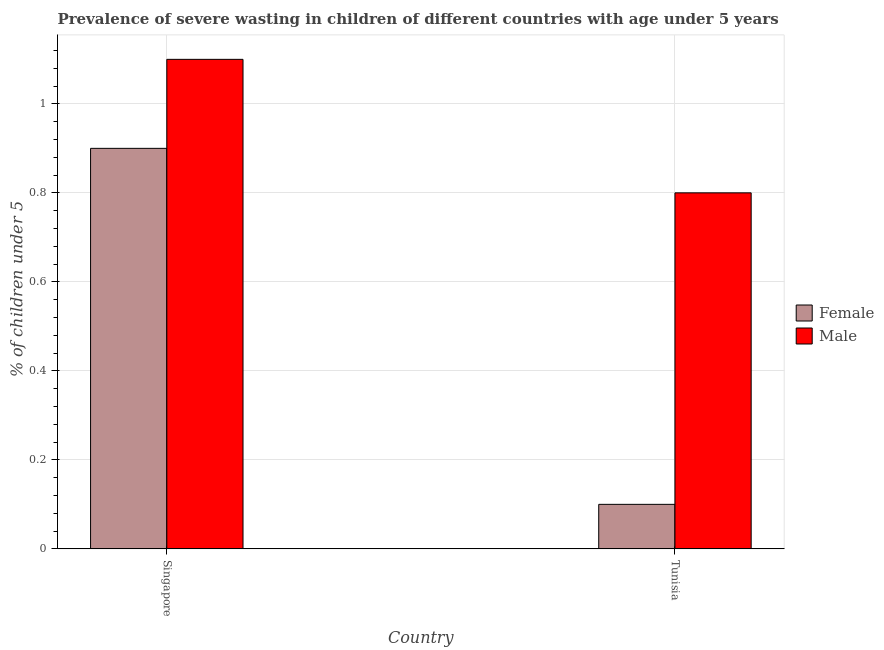How many different coloured bars are there?
Your response must be concise. 2. Are the number of bars per tick equal to the number of legend labels?
Your answer should be very brief. Yes. How many bars are there on the 2nd tick from the right?
Provide a succinct answer. 2. What is the label of the 1st group of bars from the left?
Provide a short and direct response. Singapore. What is the percentage of undernourished male children in Tunisia?
Ensure brevity in your answer.  0.8. Across all countries, what is the maximum percentage of undernourished male children?
Make the answer very short. 1.1. Across all countries, what is the minimum percentage of undernourished male children?
Provide a short and direct response. 0.8. In which country was the percentage of undernourished male children maximum?
Provide a succinct answer. Singapore. In which country was the percentage of undernourished female children minimum?
Your answer should be very brief. Tunisia. What is the total percentage of undernourished female children in the graph?
Offer a terse response. 1. What is the difference between the percentage of undernourished female children in Singapore and that in Tunisia?
Give a very brief answer. 0.8. What is the difference between the percentage of undernourished male children in Tunisia and the percentage of undernourished female children in Singapore?
Give a very brief answer. -0.1. What is the average percentage of undernourished female children per country?
Your answer should be very brief. 0.5. What is the difference between the percentage of undernourished male children and percentage of undernourished female children in Singapore?
Offer a terse response. 0.2. In how many countries, is the percentage of undernourished male children greater than 0.88 %?
Your answer should be very brief. 1. What is the ratio of the percentage of undernourished male children in Singapore to that in Tunisia?
Make the answer very short. 1.38. Is the percentage of undernourished female children in Singapore less than that in Tunisia?
Your answer should be very brief. No. What does the 1st bar from the right in Tunisia represents?
Give a very brief answer. Male. How many bars are there?
Make the answer very short. 4. Are all the bars in the graph horizontal?
Your response must be concise. No. What is the difference between two consecutive major ticks on the Y-axis?
Your response must be concise. 0.2. Are the values on the major ticks of Y-axis written in scientific E-notation?
Make the answer very short. No. Does the graph contain any zero values?
Offer a very short reply. No. Does the graph contain grids?
Your answer should be compact. Yes. Where does the legend appear in the graph?
Provide a short and direct response. Center right. What is the title of the graph?
Provide a short and direct response. Prevalence of severe wasting in children of different countries with age under 5 years. What is the label or title of the X-axis?
Provide a succinct answer. Country. What is the label or title of the Y-axis?
Give a very brief answer.  % of children under 5. What is the  % of children under 5 of Female in Singapore?
Provide a short and direct response. 0.9. What is the  % of children under 5 in Male in Singapore?
Make the answer very short. 1.1. What is the  % of children under 5 of Female in Tunisia?
Keep it short and to the point. 0.1. What is the  % of children under 5 in Male in Tunisia?
Provide a short and direct response. 0.8. Across all countries, what is the maximum  % of children under 5 in Female?
Your answer should be very brief. 0.9. Across all countries, what is the maximum  % of children under 5 in Male?
Your response must be concise. 1.1. Across all countries, what is the minimum  % of children under 5 in Female?
Offer a very short reply. 0.1. Across all countries, what is the minimum  % of children under 5 of Male?
Your answer should be compact. 0.8. What is the total  % of children under 5 of Female in the graph?
Provide a short and direct response. 1. What is the difference between the  % of children under 5 of Male in Singapore and that in Tunisia?
Give a very brief answer. 0.3. What is the difference between the  % of children under 5 in Female in Singapore and the  % of children under 5 in Male in Tunisia?
Keep it short and to the point. 0.1. What is the average  % of children under 5 in Female per country?
Ensure brevity in your answer.  0.5. What is the difference between the  % of children under 5 in Female and  % of children under 5 in Male in Singapore?
Offer a terse response. -0.2. What is the difference between the  % of children under 5 of Female and  % of children under 5 of Male in Tunisia?
Provide a succinct answer. -0.7. What is the ratio of the  % of children under 5 of Male in Singapore to that in Tunisia?
Provide a short and direct response. 1.38. What is the difference between the highest and the second highest  % of children under 5 in Male?
Give a very brief answer. 0.3. What is the difference between the highest and the lowest  % of children under 5 in Female?
Offer a terse response. 0.8. 